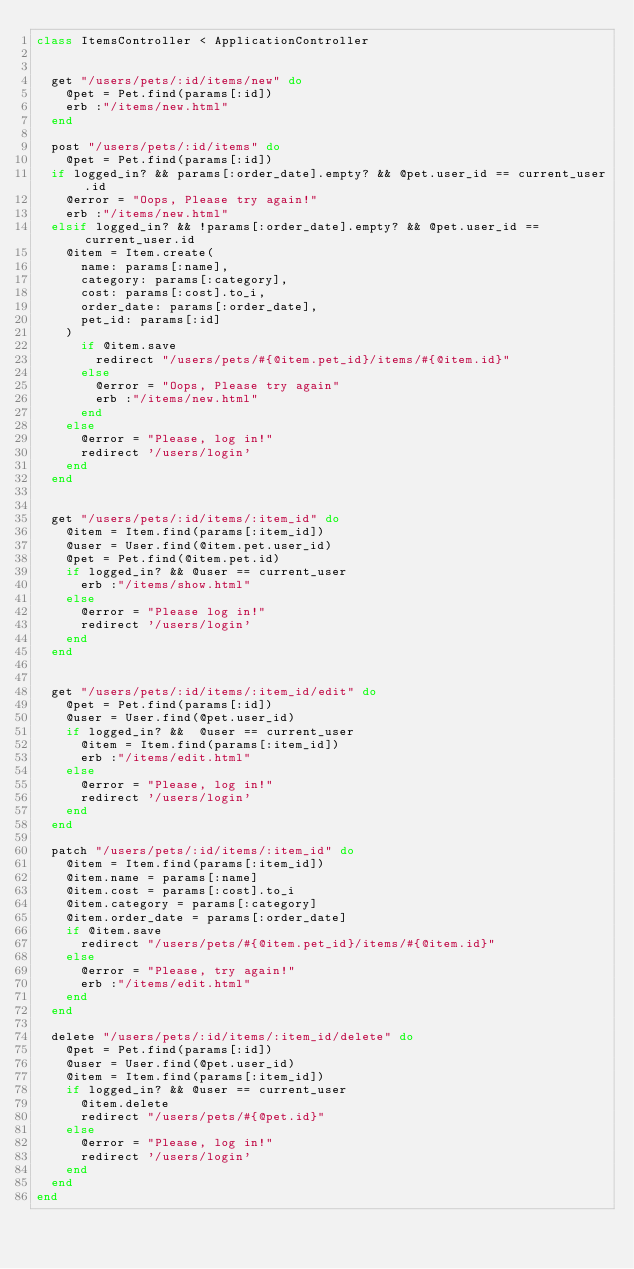<code> <loc_0><loc_0><loc_500><loc_500><_Ruby_>class ItemsController < ApplicationController


  get "/users/pets/:id/items/new" do
    @pet = Pet.find(params[:id])
    erb :"/items/new.html"
  end

  post "/users/pets/:id/items" do
    @pet = Pet.find(params[:id])
  if logged_in? && params[:order_date].empty? && @pet.user_id == current_user.id
    @error = "Oops, Please try again!" 
    erb :"/items/new.html"
  elsif logged_in? && !params[:order_date].empty? && @pet.user_id == current_user.id
    @item = Item.create(
      name: params[:name],
      category: params[:category],
      cost: params[:cost].to_i,
      order_date: params[:order_date],
      pet_id: params[:id]
    )
      if @item.save
        redirect "/users/pets/#{@item.pet_id}/items/#{@item.id}"
      else
        @error = "Oops, Please try again"
        erb :"/items/new.html"
      end
    else
      @error = "Please, log in!"
      redirect '/users/login'
    end
  end


  get "/users/pets/:id/items/:item_id" do
    @item = Item.find(params[:item_id])
    @user = User.find(@item.pet.user_id)
    @pet = Pet.find(@item.pet.id)
    if logged_in? && @user == current_user
      erb :"/items/show.html"
    else
      @error = "Please log in!"
      redirect '/users/login'
    end
  end


  get "/users/pets/:id/items/:item_id/edit" do
    @pet = Pet.find(params[:id])
    @user = User.find(@pet.user_id)
    if logged_in? &&  @user == current_user
      @item = Item.find(params[:item_id])
      erb :"/items/edit.html"
    else
      @error = "Please, log in!"
      redirect '/users/login'
    end
  end

  patch "/users/pets/:id/items/:item_id" do
    @item = Item.find(params[:item_id])
    @item.name = params[:name]
    @item.cost = params[:cost].to_i
    @item.category = params[:category]
    @item.order_date = params[:order_date]
    if @item.save
      redirect "/users/pets/#{@item.pet_id}/items/#{@item.id}"
    else
      @error = "Please, try again!"
      erb :"/items/edit.html"
    end
  end

  delete "/users/pets/:id/items/:item_id/delete" do
    @pet = Pet.find(params[:id])
    @user = User.find(@pet.user_id)
    @item = Item.find(params[:item_id])
    if logged_in? && @user == current_user
      @item.delete
      redirect "/users/pets/#{@pet.id}"
    else
      @error = "Please, log in!"
      redirect '/users/login'
    end
  end
end
</code> 